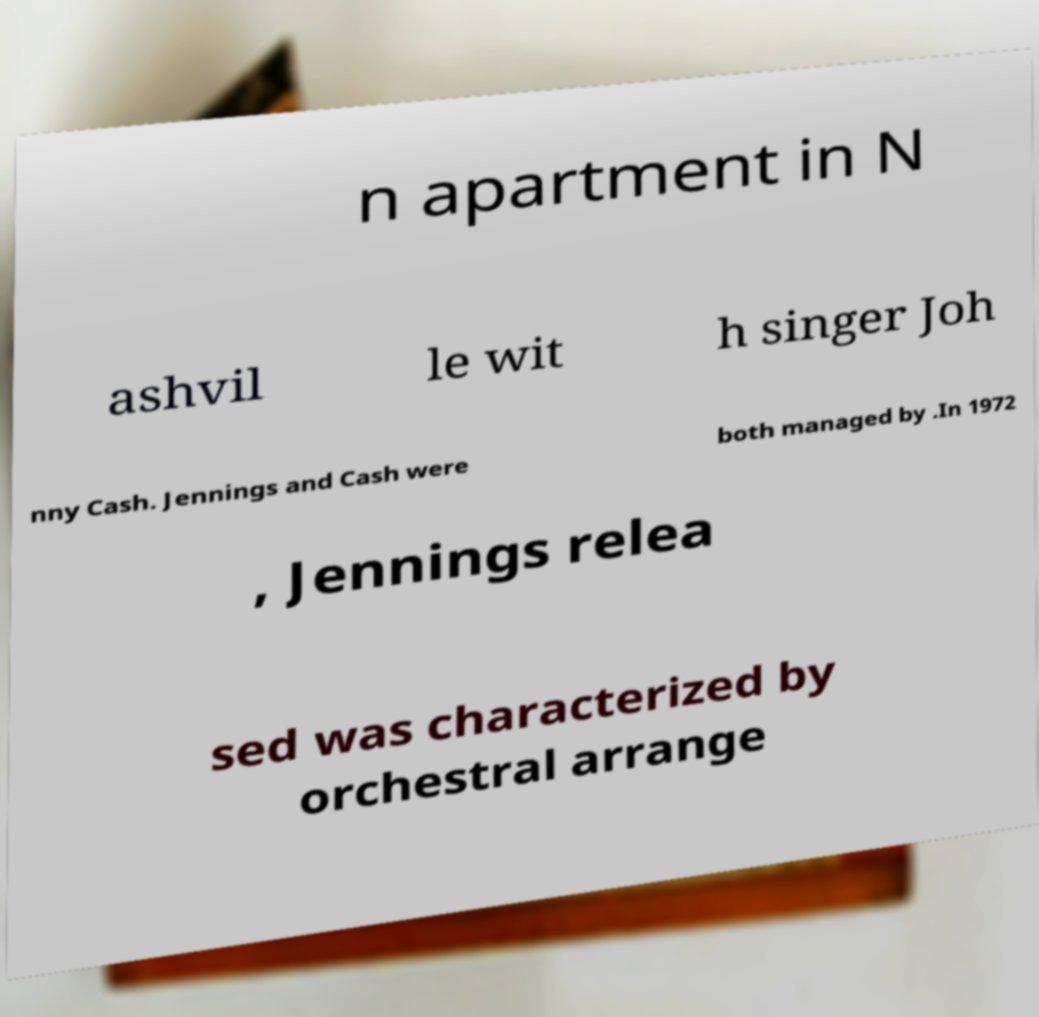I need the written content from this picture converted into text. Can you do that? n apartment in N ashvil le wit h singer Joh nny Cash. Jennings and Cash were both managed by .In 1972 , Jennings relea sed was characterized by orchestral arrange 